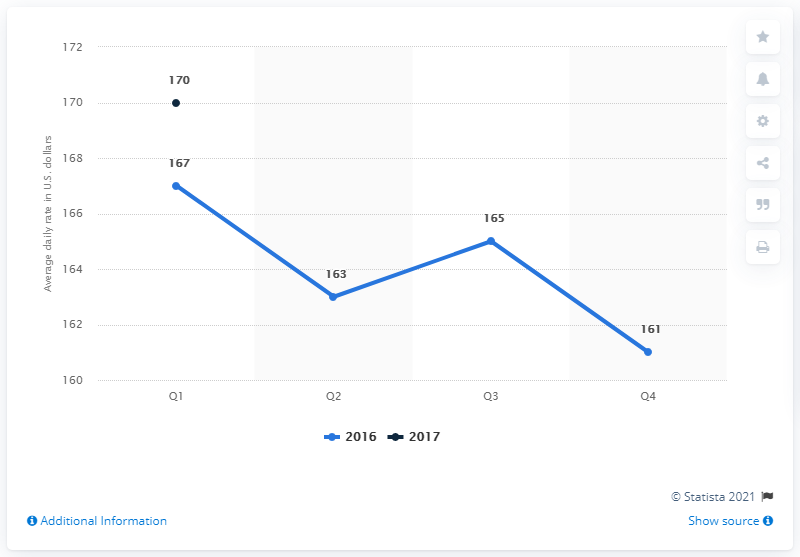Highlight a few significant elements in this photo. The average daily rate of hotels in Atlanta during the first quarter of 2017 was approximately 170 dollars. The average rate of Q1 and Q2 is 5.5. The average rate for Q1 is 167. 